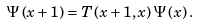Convert formula to latex. <formula><loc_0><loc_0><loc_500><loc_500>\Psi \left ( x + 1 \right ) = T \left ( x + 1 , x \right ) \Psi \left ( x \right ) .</formula> 